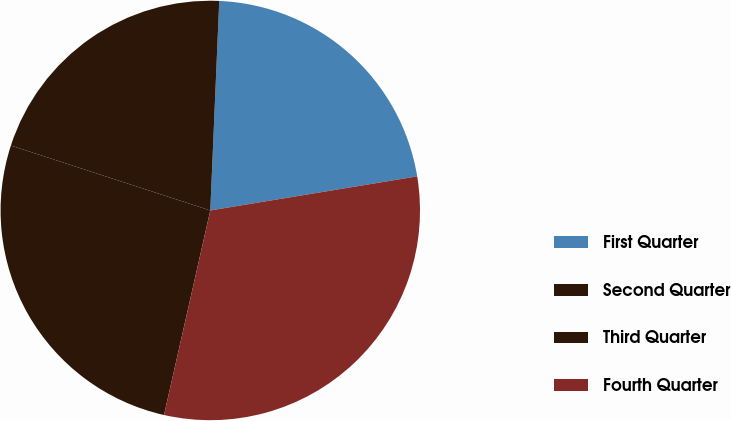Convert chart. <chart><loc_0><loc_0><loc_500><loc_500><pie_chart><fcel>First Quarter<fcel>Second Quarter<fcel>Third Quarter<fcel>Fourth Quarter<nl><fcel>21.72%<fcel>20.67%<fcel>26.47%<fcel>31.14%<nl></chart> 